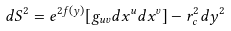Convert formula to latex. <formula><loc_0><loc_0><loc_500><loc_500>d S ^ { 2 } = e ^ { 2 f ( y ) } [ g _ { u v } d x ^ { u } d x ^ { v } ] - r _ { c } ^ { 2 } d y ^ { 2 }</formula> 